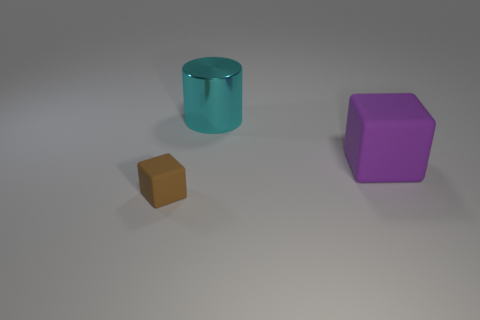How many things are either tiny brown things or rubber cubes that are in front of the big purple thing?
Your answer should be very brief. 1. Is the number of brown blocks that are left of the small brown block greater than the number of large metal objects that are right of the big purple thing?
Your response must be concise. No. What shape is the rubber thing on the right side of the cube left of the cyan shiny cylinder right of the small rubber object?
Give a very brief answer. Cube. There is a object in front of the cube that is behind the tiny block; what is its shape?
Your response must be concise. Cube. Is there a brown object that has the same material as the large cylinder?
Make the answer very short. No. How many red objects are big cubes or large cylinders?
Your answer should be very brief. 0. Are there any tiny matte objects that have the same color as the big cylinder?
Give a very brief answer. No. There is a brown thing that is the same material as the purple thing; what is its size?
Keep it short and to the point. Small. What number of cylinders are either large yellow shiny objects or cyan objects?
Make the answer very short. 1. Is the number of small brown matte cubes greater than the number of big purple shiny objects?
Offer a terse response. Yes. 